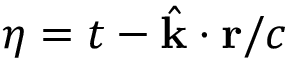<formula> <loc_0><loc_0><loc_500><loc_500>\eta = t - \hat { k } \cdot r / c</formula> 